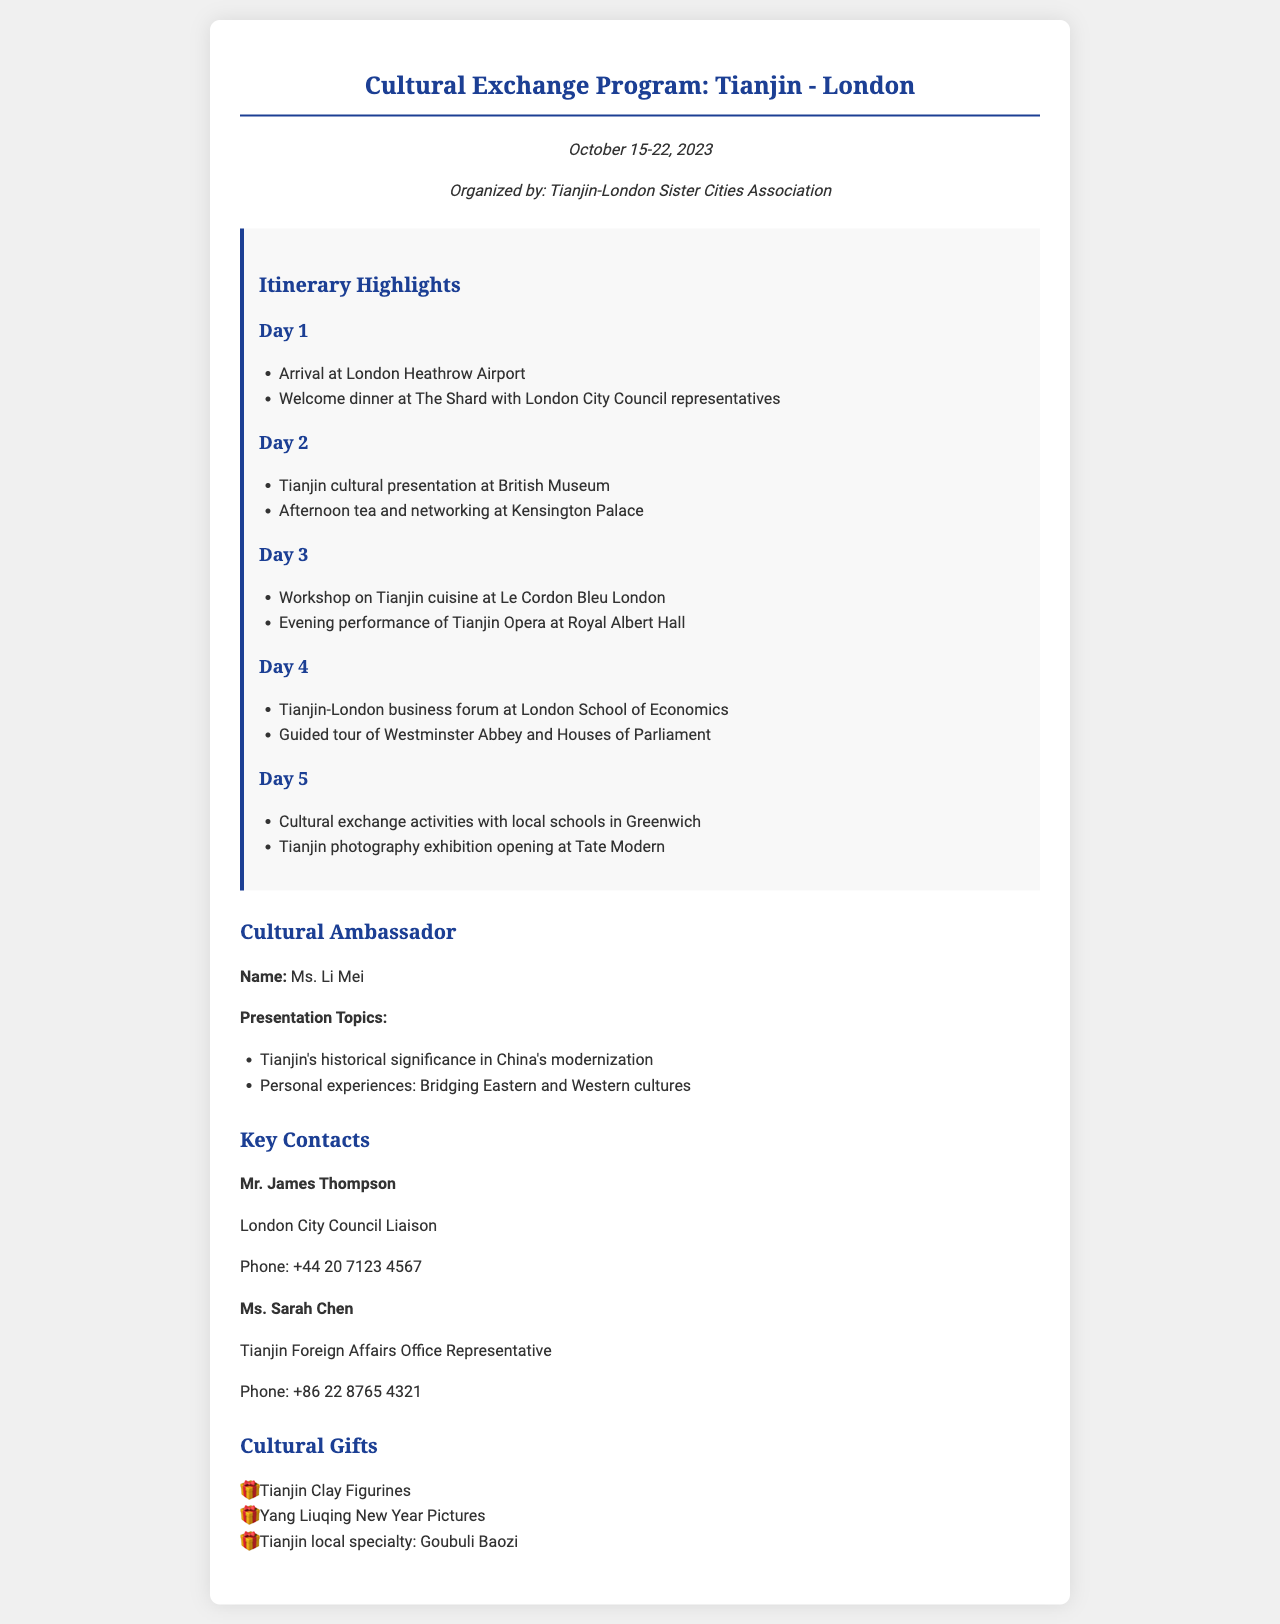What are the program dates? The program runs from October 15 to October 22, 2023, as mentioned in the document header.
Answer: October 15-22, 2023 Who is the Cultural Ambassador? The document specifies that Ms. Li Mei is the Cultural Ambassador for the program.
Answer: Ms. Li Mei What is the location of the welcome dinner? The welcome dinner takes place at The Shard, as indicated in the Day 1 itinerary.
Answer: The Shard What is one topic of Ms. Li Mei's presentation? The document lists Tianjin's historical significance in China's modernization as one of the presentation topics.
Answer: Tianjin's historical significance in China's modernization Which day features a workshop on Tianjin cuisine? The itinerary for Day 3 includes a workshop on Tianjin cuisine.
Answer: Day 3 What cultural gift is mentioned that relates to Tianjin? The document lists Tianjin Clay Figurines as one of the cultural gifts.
Answer: Tianjin Clay Figurines Who is the contact for the London City Council? Mr. James Thompson is identified as the contact for the London City Council in the document.
Answer: Mr. James Thompson What type of activities occur with local schools? The document refers to cultural exchange activities with local schools as part of the program on Day 5.
Answer: Cultural exchange activities What organization is responsible for organizing the program? The Tianjin-London Sister Cities Association organized the cultural exchange program.
Answer: Tianjin-London Sister Cities Association 